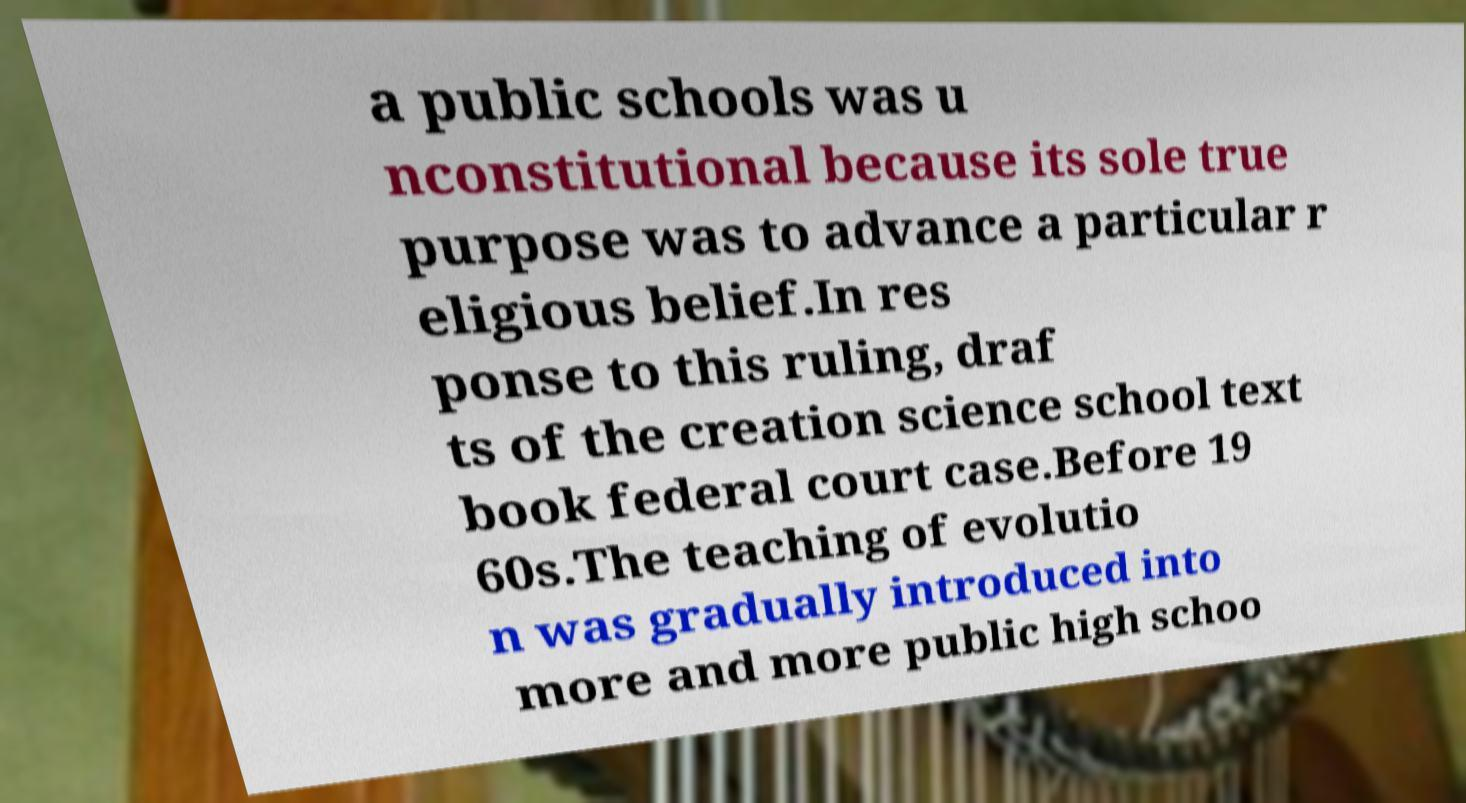I need the written content from this picture converted into text. Can you do that? a public schools was u nconstitutional because its sole true purpose was to advance a particular r eligious belief.In res ponse to this ruling, draf ts of the creation science school text book federal court case.Before 19 60s.The teaching of evolutio n was gradually introduced into more and more public high schoo 